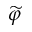Convert formula to latex. <formula><loc_0><loc_0><loc_500><loc_500>\widetilde { \varphi }</formula> 